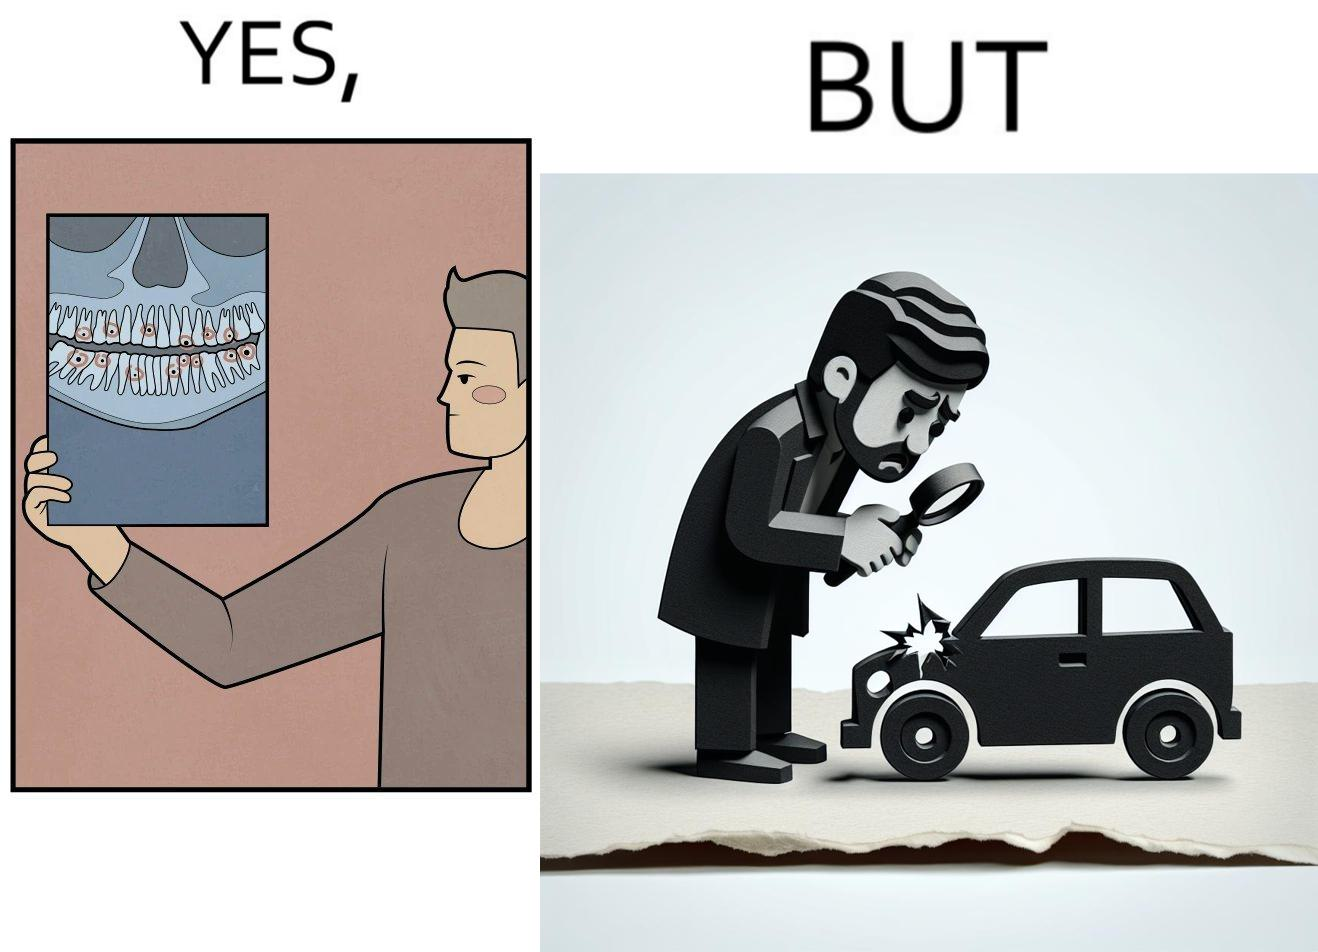What is shown in the left half versus the right half of this image? In the left part of the image: It is a man looking at an image of his cavity filled teeth In the right part of the image: It is a man looking worried after seeing a microscopic hole in his car 